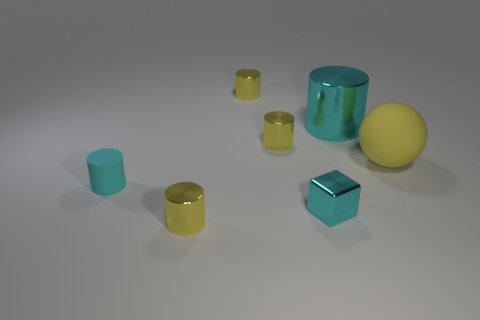Subtract all yellow cylinders. How many were subtracted if there are1yellow cylinders left? 2 Subtract all purple cubes. How many yellow cylinders are left? 3 Subtract 1 cylinders. How many cylinders are left? 4 Subtract all tiny cyan cylinders. How many cylinders are left? 4 Add 1 small cyan cylinders. How many objects exist? 8 Subtract all purple cylinders. Subtract all brown cubes. How many cylinders are left? 5 Subtract all blocks. How many objects are left? 6 Subtract 0 green cylinders. How many objects are left? 7 Subtract all big balls. Subtract all large rubber things. How many objects are left? 5 Add 3 large objects. How many large objects are left? 5 